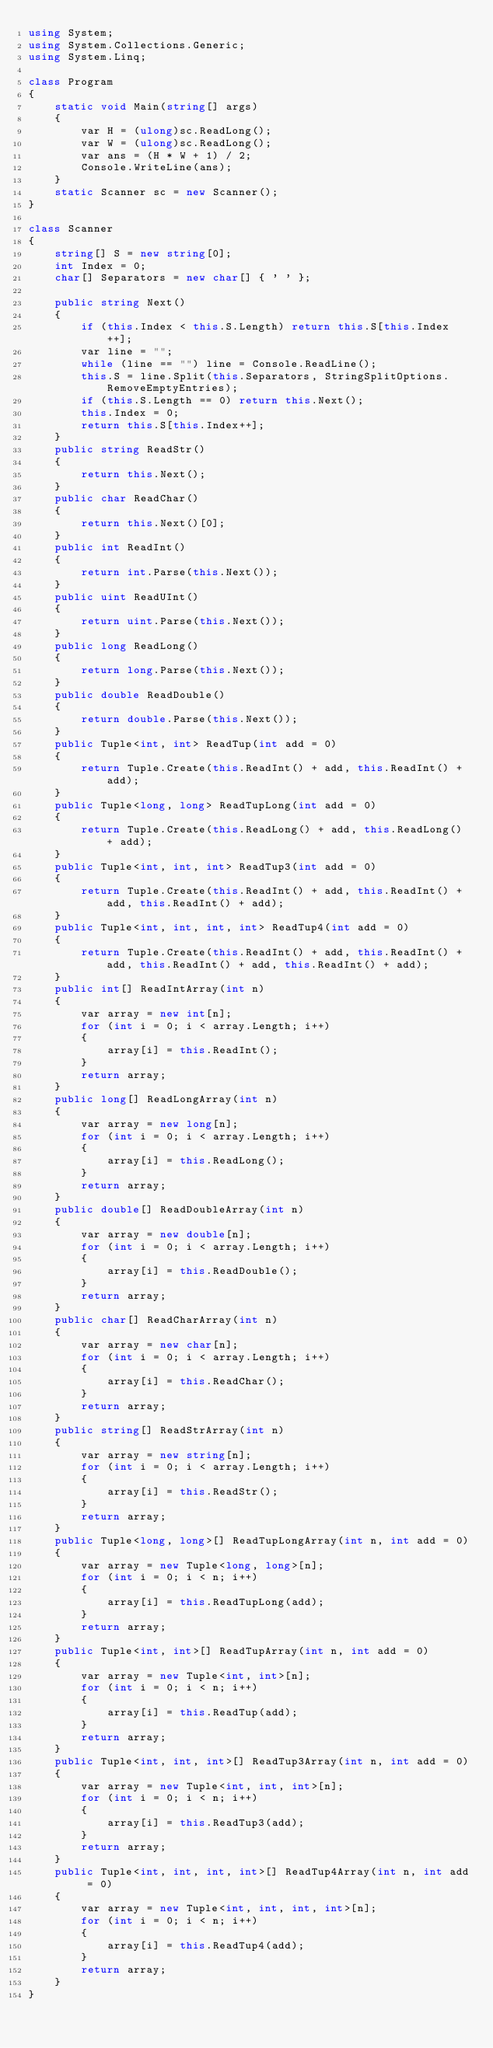<code> <loc_0><loc_0><loc_500><loc_500><_C#_>using System;
using System.Collections.Generic;
using System.Linq;

class Program
{
    static void Main(string[] args)
    {
        var H = (ulong)sc.ReadLong();
        var W = (ulong)sc.ReadLong();
        var ans = (H * W + 1) / 2;
        Console.WriteLine(ans);
    }
    static Scanner sc = new Scanner();
}

class Scanner
{
    string[] S = new string[0];
    int Index = 0;
    char[] Separators = new char[] { ' ' };

    public string Next()
    {
        if (this.Index < this.S.Length) return this.S[this.Index++];
        var line = "";
        while (line == "") line = Console.ReadLine();
        this.S = line.Split(this.Separators, StringSplitOptions.RemoveEmptyEntries);
        if (this.S.Length == 0) return this.Next();
        this.Index = 0;
        return this.S[this.Index++];
    }
    public string ReadStr()
    {
        return this.Next();
    }
    public char ReadChar()
    {
        return this.Next()[0];
    }
    public int ReadInt()
    {
        return int.Parse(this.Next());
    }
    public uint ReadUInt()
    {
        return uint.Parse(this.Next());
    }
    public long ReadLong()
    {
        return long.Parse(this.Next());
    }
    public double ReadDouble()
    {
        return double.Parse(this.Next());
    }
    public Tuple<int, int> ReadTup(int add = 0)
    {
        return Tuple.Create(this.ReadInt() + add, this.ReadInt() + add);
    }
    public Tuple<long, long> ReadTupLong(int add = 0)
    {
        return Tuple.Create(this.ReadLong() + add, this.ReadLong() + add);
    }
    public Tuple<int, int, int> ReadTup3(int add = 0)
    {
        return Tuple.Create(this.ReadInt() + add, this.ReadInt() + add, this.ReadInt() + add);
    }
    public Tuple<int, int, int, int> ReadTup4(int add = 0)
    {
        return Tuple.Create(this.ReadInt() + add, this.ReadInt() + add, this.ReadInt() + add, this.ReadInt() + add);
    }
    public int[] ReadIntArray(int n)
    {
        var array = new int[n];
        for (int i = 0; i < array.Length; i++)
        {
            array[i] = this.ReadInt();
        }
        return array;
    }
    public long[] ReadLongArray(int n)
    {
        var array = new long[n];
        for (int i = 0; i < array.Length; i++)
        {
            array[i] = this.ReadLong();
        }
        return array;
    }
    public double[] ReadDoubleArray(int n)
    {
        var array = new double[n];
        for (int i = 0; i < array.Length; i++)
        {
            array[i] = this.ReadDouble();
        }
        return array;
    }
    public char[] ReadCharArray(int n)
    {
        var array = new char[n];
        for (int i = 0; i < array.Length; i++)
        {
            array[i] = this.ReadChar();
        }
        return array;
    }
    public string[] ReadStrArray(int n)
    {
        var array = new string[n];
        for (int i = 0; i < array.Length; i++)
        {
            array[i] = this.ReadStr();
        }
        return array;
    }
    public Tuple<long, long>[] ReadTupLongArray(int n, int add = 0)
    {
        var array = new Tuple<long, long>[n];
        for (int i = 0; i < n; i++)
        {
            array[i] = this.ReadTupLong(add);
        }
        return array;
    }
    public Tuple<int, int>[] ReadTupArray(int n, int add = 0)
    {
        var array = new Tuple<int, int>[n];
        for (int i = 0; i < n; i++)
        {
            array[i] = this.ReadTup(add);
        }
        return array;
    }
    public Tuple<int, int, int>[] ReadTup3Array(int n, int add = 0)
    {
        var array = new Tuple<int, int, int>[n];
        for (int i = 0; i < n; i++)
        {
            array[i] = this.ReadTup3(add);
        }
        return array;
    }
    public Tuple<int, int, int, int>[] ReadTup4Array(int n, int add = 0)
    {
        var array = new Tuple<int, int, int, int>[n];
        for (int i = 0; i < n; i++)
        {
            array[i] = this.ReadTup4(add);
        }
        return array;
    }
}
</code> 